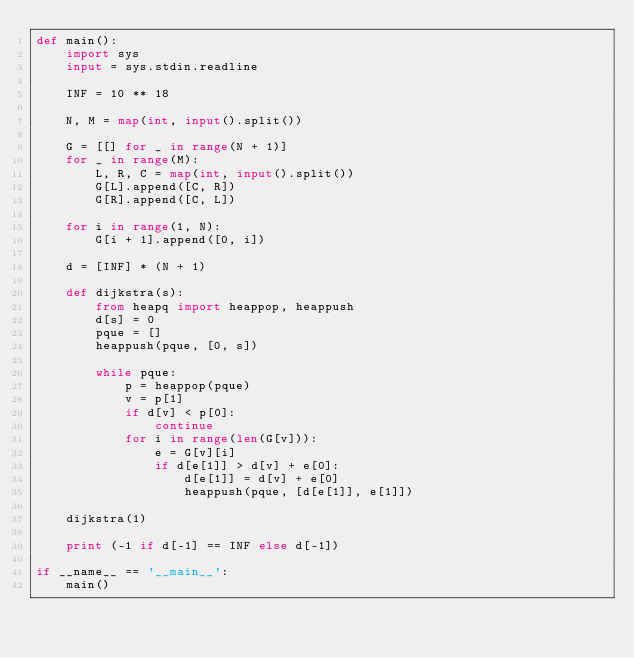<code> <loc_0><loc_0><loc_500><loc_500><_Python_>def main():
    import sys
    input = sys.stdin.readline

    INF = 10 ** 18

    N, M = map(int, input().split())

    G = [[] for _ in range(N + 1)]
    for _ in range(M):
        L, R, C = map(int, input().split())
        G[L].append([C, R])
        G[R].append([C, L])

    for i in range(1, N):
        G[i + 1].append([0, i])

    d = [INF] * (N + 1)

    def dijkstra(s):
        from heapq import heappop, heappush
        d[s] = 0
        pque = []
        heappush(pque, [0, s])
        
        while pque:
            p = heappop(pque)
            v = p[1]
            if d[v] < p[0]:
                continue
            for i in range(len(G[v])):
                e = G[v][i]
                if d[e[1]] > d[v] + e[0]:
                    d[e[1]] = d[v] + e[0]
                    heappush(pque, [d[e[1]], e[1]])

    dijkstra(1)

    print (-1 if d[-1] == INF else d[-1])

if __name__ == '__main__':
    main()</code> 